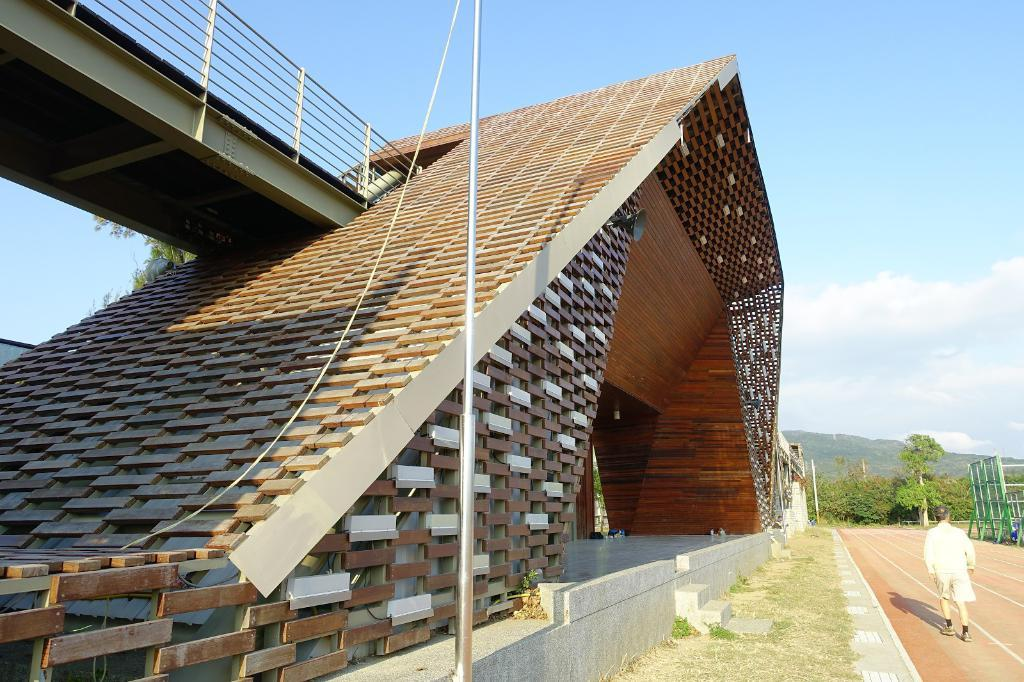What is the person in the image doing? There is a person walking in the image. What structure is near the person? There is a bridge beside the person. What type of natural environment can be seen in the image? There are trees and mountains visible in the image. What additional objects can be seen in the image? There is a pole and a rope in the image. What is visible in the sky in the image? The sky is visible in the image. What type of calculator is the person using while walking in the image? There is no calculator present in the image; the person is simply walking. 